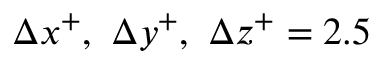Convert formula to latex. <formula><loc_0><loc_0><loc_500><loc_500>\Delta x ^ { + } , \Delta y ^ { + } , \Delta z ^ { + } = 2 . 5</formula> 